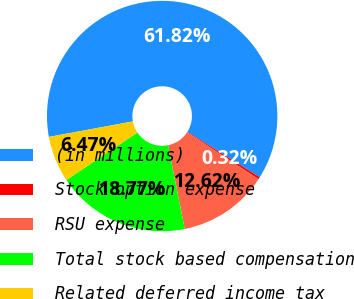Convert chart. <chart><loc_0><loc_0><loc_500><loc_500><pie_chart><fcel>(in millions)<fcel>Stock option expense<fcel>RSU expense<fcel>Total stock based compensation<fcel>Related deferred income tax<nl><fcel>61.81%<fcel>0.32%<fcel>12.62%<fcel>18.77%<fcel>6.47%<nl></chart> 